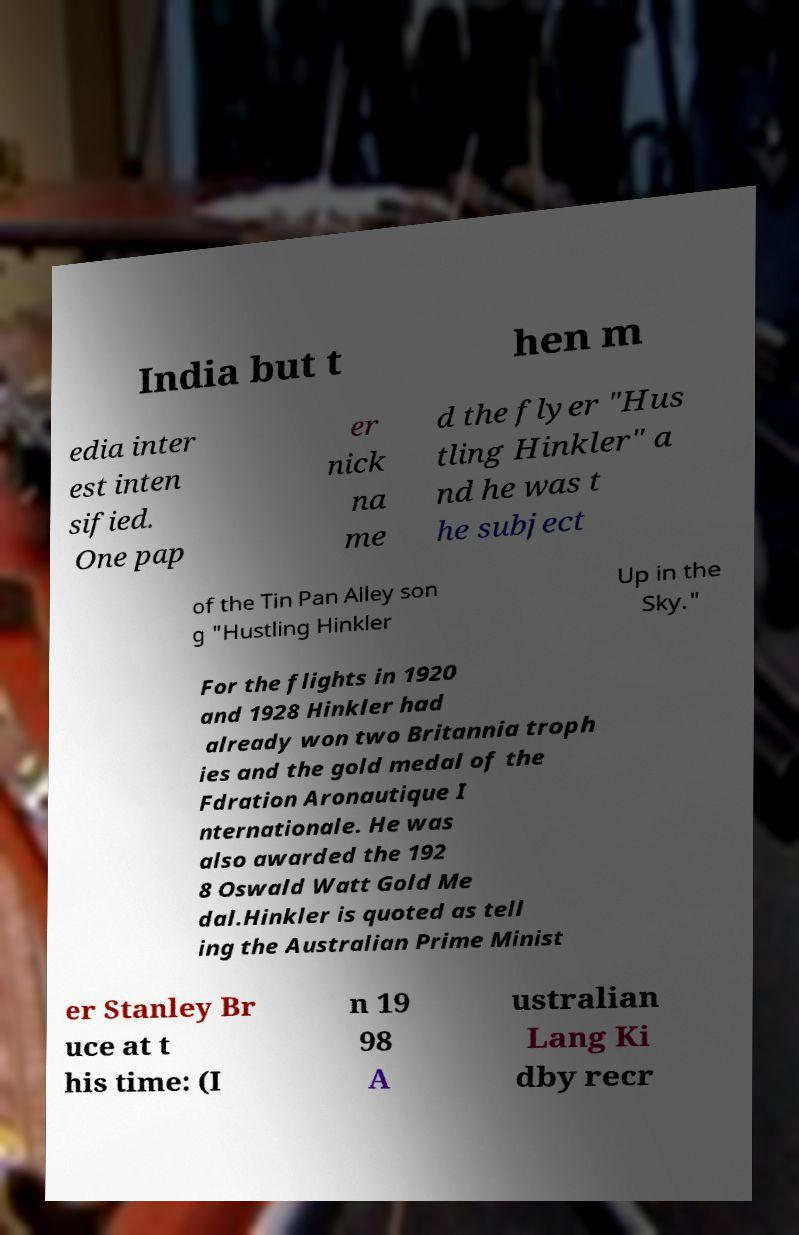Please identify and transcribe the text found in this image. India but t hen m edia inter est inten sified. One pap er nick na me d the flyer "Hus tling Hinkler" a nd he was t he subject of the Tin Pan Alley son g "Hustling Hinkler Up in the Sky." For the flights in 1920 and 1928 Hinkler had already won two Britannia troph ies and the gold medal of the Fdration Aronautique I nternationale. He was also awarded the 192 8 Oswald Watt Gold Me dal.Hinkler is quoted as tell ing the Australian Prime Minist er Stanley Br uce at t his time: (I n 19 98 A ustralian Lang Ki dby recr 